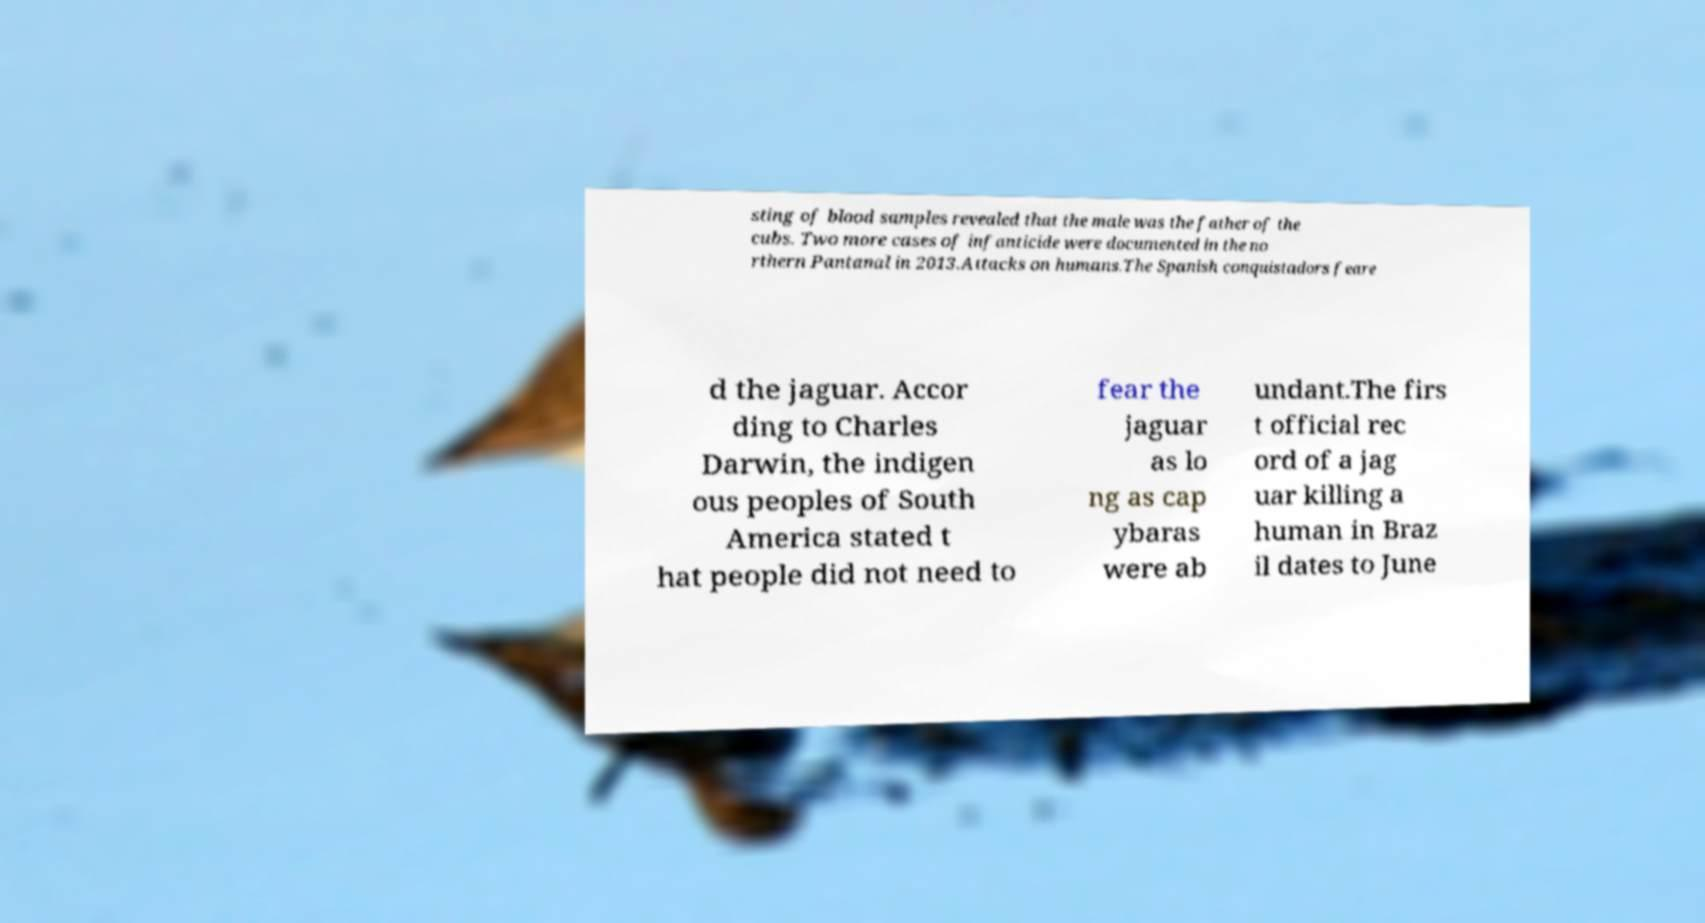Can you accurately transcribe the text from the provided image for me? sting of blood samples revealed that the male was the father of the cubs. Two more cases of infanticide were documented in the no rthern Pantanal in 2013.Attacks on humans.The Spanish conquistadors feare d the jaguar. Accor ding to Charles Darwin, the indigen ous peoples of South America stated t hat people did not need to fear the jaguar as lo ng as cap ybaras were ab undant.The firs t official rec ord of a jag uar killing a human in Braz il dates to June 